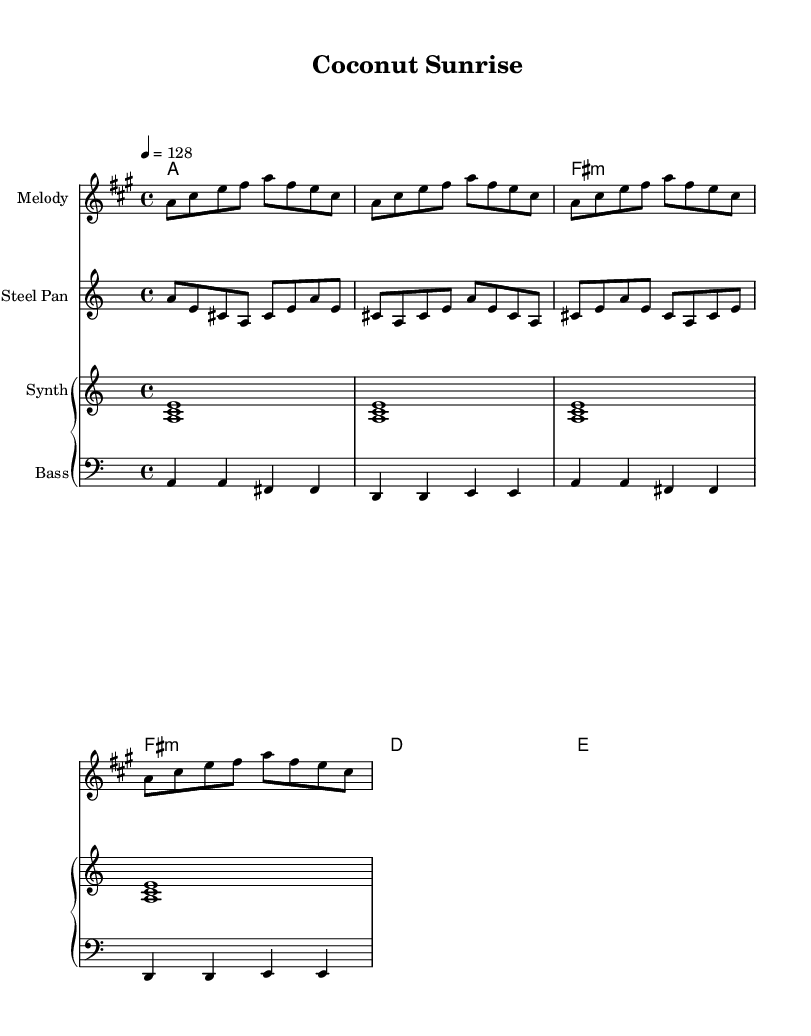What is the key signature of this music? The key signature is A major, which has three sharps (F#, C#, G#). This can be determined by recognizing the notation used at the beginning of the staff, which indicates the sharps associated with the key.
Answer: A major What is the time signature of this piece? The time signature is 4/4, which is indicated at the beginning of the score. This means there are four beats per measure, and a quarter note gets one beat.
Answer: 4/4 What is the tempo marking for this piece? The tempo marking indicates that the piece should be played at a speed of 128 beats per minute. This is found at the beginning of the score where the tempo is specified.
Answer: 128 How many times does the melody repeat in the score? The melody is repeated four times, as indicated by the repeated measure patterns in the notation, which show the same sequence of notes played in succession without variation.
Answer: 4 What instrument plays the steelpan part? The steelpan part is indicated by the specific staff labeled "Steel Pan" in the score, showing the distinct rhythm and melody that are characteristic of this instrument.
Answer: Steel Pan What type of chord is played in the second measure of harmonies? The second measure of harmonies features an A major chord as indicated by the chord name written above it, which specifies the harmony that aligns with the melody.
Answer: A major Which instrument plays the bassline on the first measure? The bassline on the first measure is played by the staff labeled "Bass," where the notes are written in a lower octave indicating that this part is for a bass instrument.
Answer: Bass 